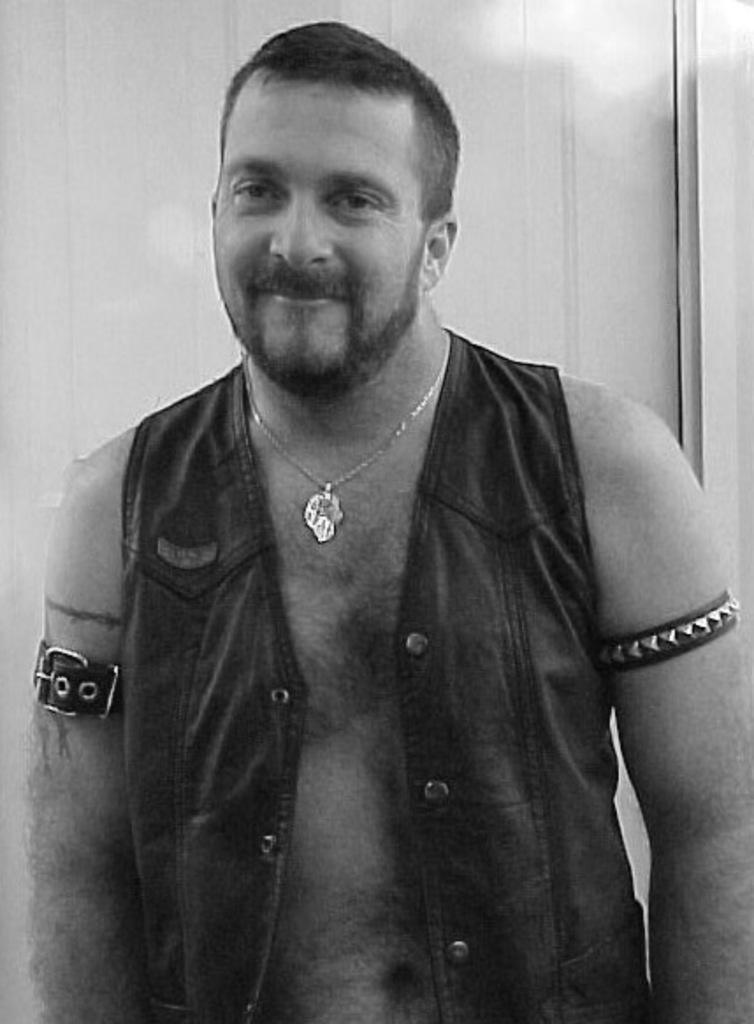Could you give a brief overview of what you see in this image? In this picture there is a man in the center of the image. 